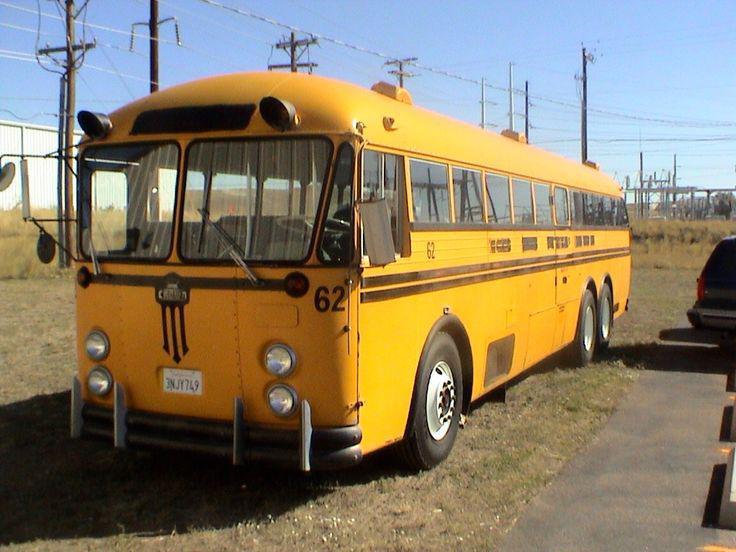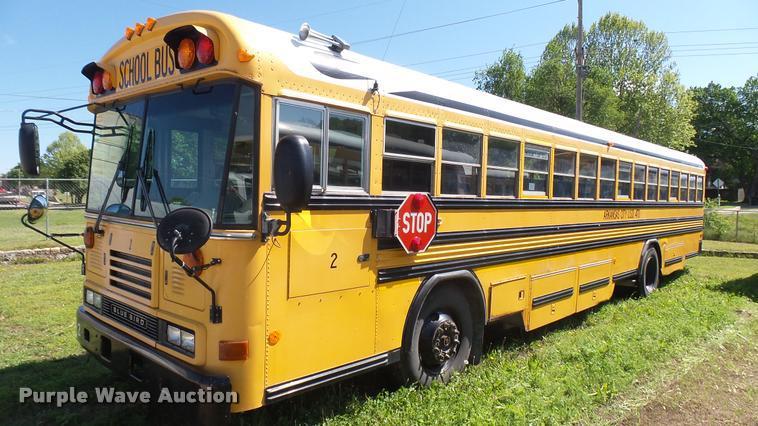The first image is the image on the left, the second image is the image on the right. For the images shown, is this caption "Exactly one bus' doors are open." true? Answer yes or no. No. The first image is the image on the left, the second image is the image on the right. Examine the images to the left and right. Is the description "Both buses are facing diagonally and to the same side." accurate? Answer yes or no. Yes. 